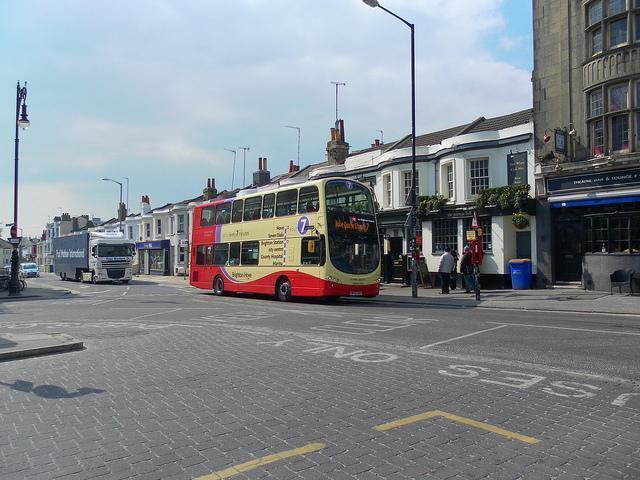How many levels does this bus have?
Give a very brief answer. 2. How many trucks do you see?
Give a very brief answer. 1. 